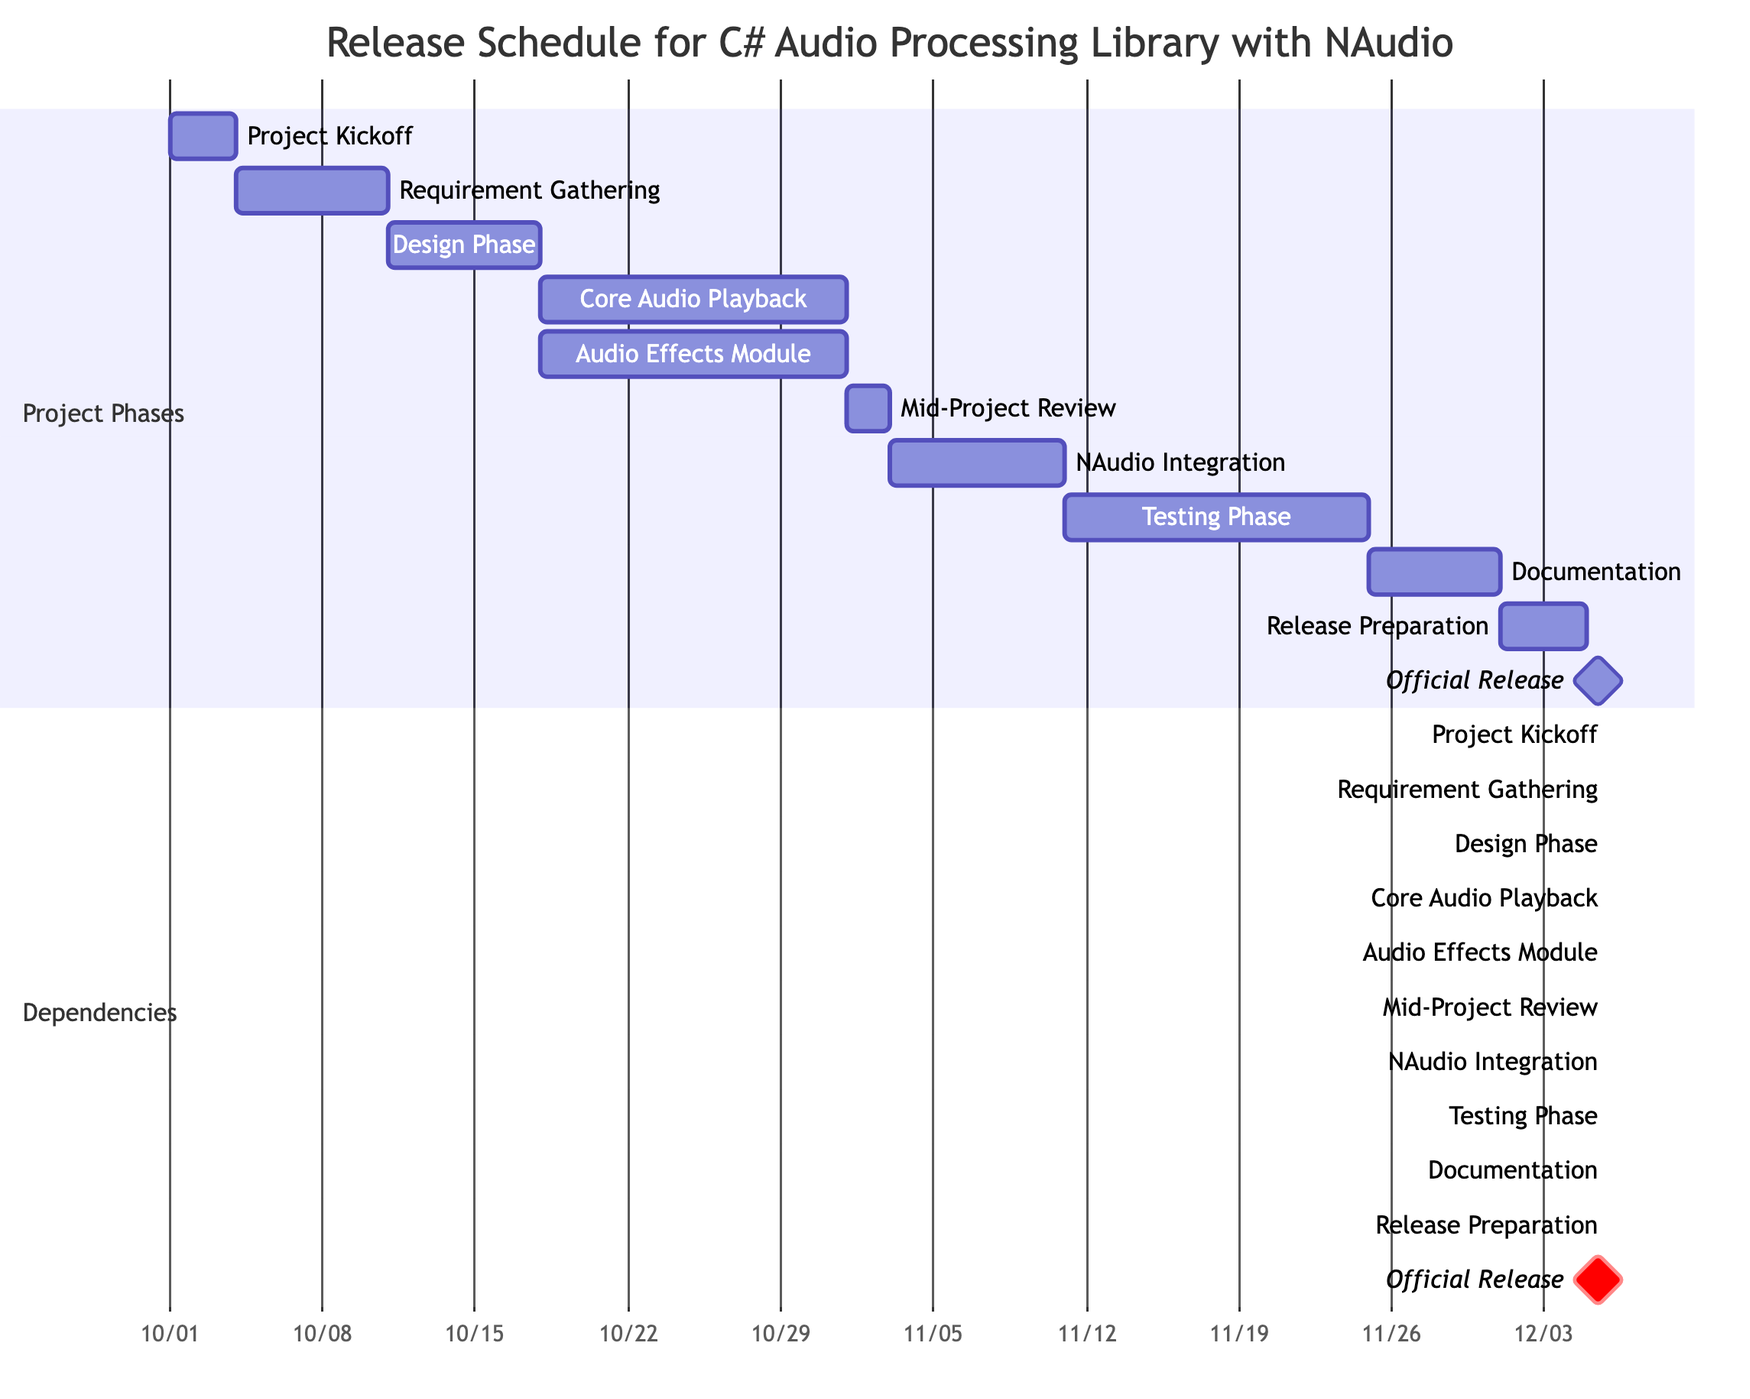What is the duration of the "Implementation Phase - Core Audio Playback"? From the Gantt chart, we see that the "Implementation Phase - Core Audio Playback" starts on October 18, 2023, and ends on October 31, 2023. The duration can be calculated as 31 - 18 + 1 = 14 days.
Answer: 14 days What task follows "Documentation Preparation"? Reviewing the dependencies for "Documentation Preparation," we notice that the subsequent task is "Release Preparation," which starts immediately after it ends on December 14, 2023.
Answer: Release Preparation How many tasks are scheduled before the "Official Release"? Counting the tasks listed before the "Official Release," we find that there are 10 tasks leading up to it: Project Kickoff, Requirement Gathering and Analysis, Design Phase, Implementation Phase - Core Audio Playback, Implementation Phase - Audio Effects Module, Mid-Project Review, Integration with NAudio Components, Testing Phase, Documentation Preparation, and Release Preparation.
Answer: 10 tasks Which task has the earliest start date? By examining the start dates of all tasks, we see that "Project Kickoff" starts on October 1, 2023, making it the earliest in the schedule compared to the other tasks.
Answer: Project Kickoff What is the total time allocated for the testing phase? The Testing Phase starts on November 25, 2023, and ends on December 8, 2023. By calculating the duration: 8 - 25 + 1 = 14 days. Hence, the total time allocated here is 14 days.
Answer: 14 days Which task is dependent on both "Implementation Phase - Core Audio Playback" and "Implementation Phase - Audio Effects Module"? In examining the dependencies, we identify that the "Mid-Project Review" task is reliant on both tasks before it, which is indicated clearly by the arrows in the Gantt chart.
Answer: Mid-Project Review What is the start date for the "Audio Effects Module"? Referring to the Gantt chart, we find that the "Audio Effects Module" starts on November 1, 2023, immediately following its dependent task completion.
Answer: November 1, 2023 How many days is the "Release Preparation" scheduled for? The "Release Preparation" starts on December 15, 2023, and ends on December 18, 2023. The duration can be calculated as 18 - 15 + 1 = 4 days.
Answer: 4 days Which milestone marks the final event in the release schedule? Looking at the diagram, "Official Release" is marked as the milestone event at the end of the task schedule, happening on December 19, 2023.
Answer: Official Release 